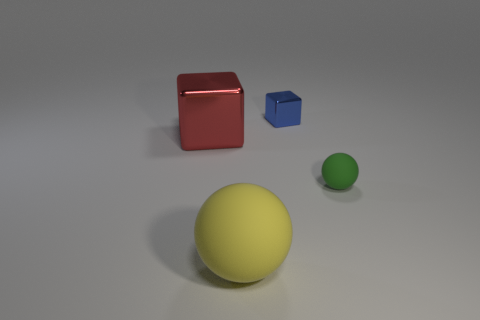Add 1 large red blocks. How many objects exist? 5 Subtract all red blocks. How many blocks are left? 1 Subtract 1 blue cubes. How many objects are left? 3 Subtract all cyan balls. Subtract all yellow cubes. How many balls are left? 2 Subtract all gray balls. How many cyan blocks are left? 0 Subtract all big cyan metallic balls. Subtract all large red things. How many objects are left? 3 Add 1 spheres. How many spheres are left? 3 Add 4 purple metallic spheres. How many purple metallic spheres exist? 4 